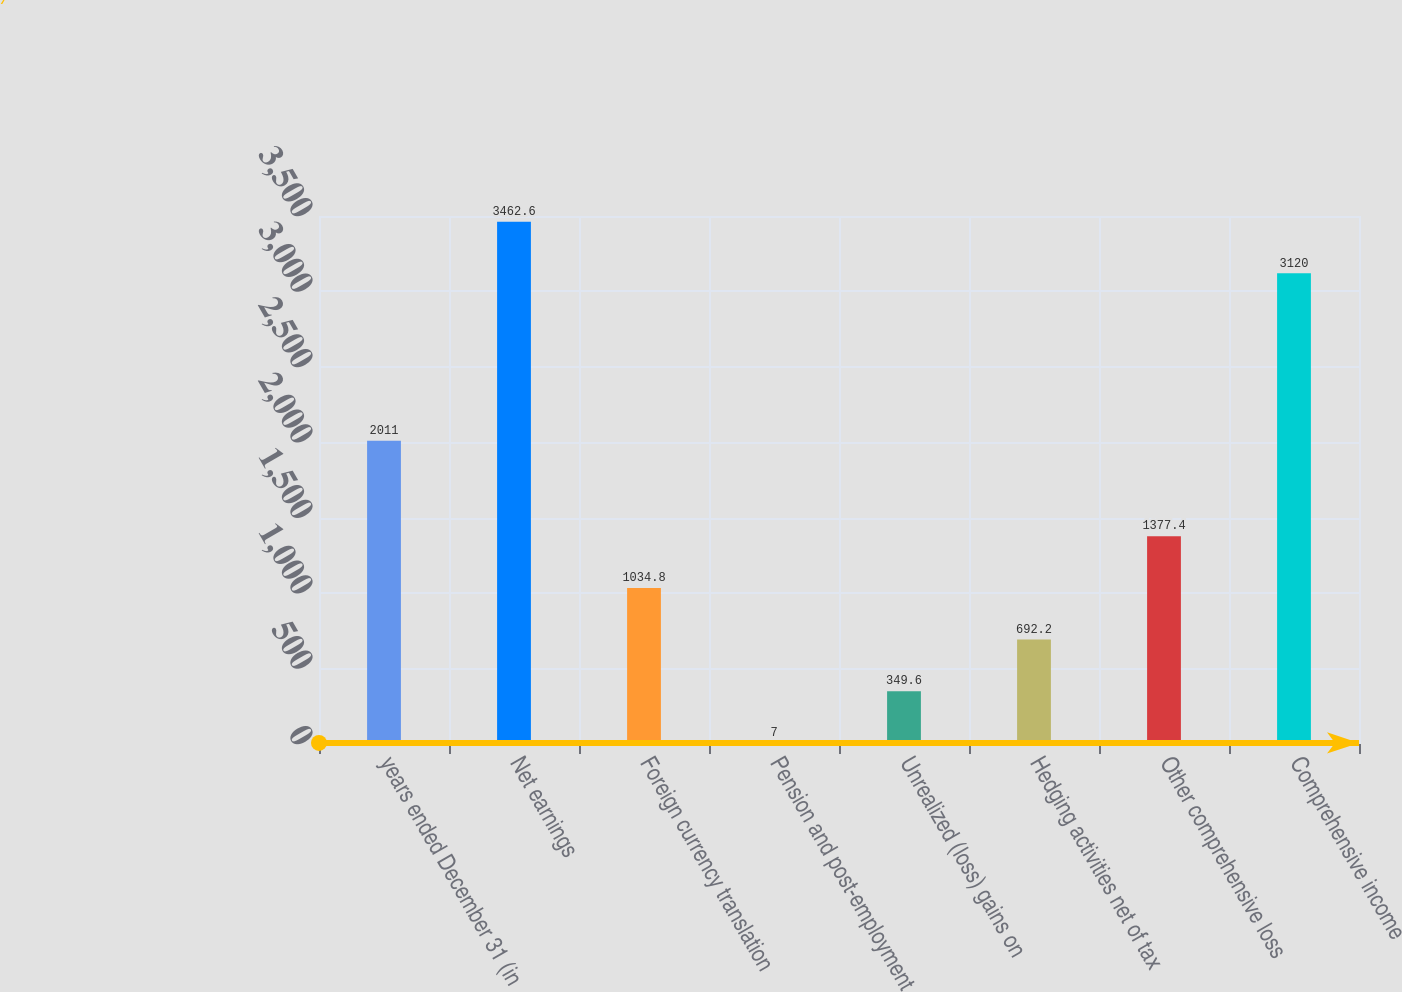<chart> <loc_0><loc_0><loc_500><loc_500><bar_chart><fcel>years ended December 31 (in<fcel>Net earnings<fcel>Foreign currency translation<fcel>Pension and post-employment<fcel>Unrealized (loss) gains on<fcel>Hedging activities net of tax<fcel>Other comprehensive loss<fcel>Comprehensive income<nl><fcel>2011<fcel>3462.6<fcel>1034.8<fcel>7<fcel>349.6<fcel>692.2<fcel>1377.4<fcel>3120<nl></chart> 